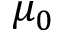<formula> <loc_0><loc_0><loc_500><loc_500>\mu _ { 0 }</formula> 